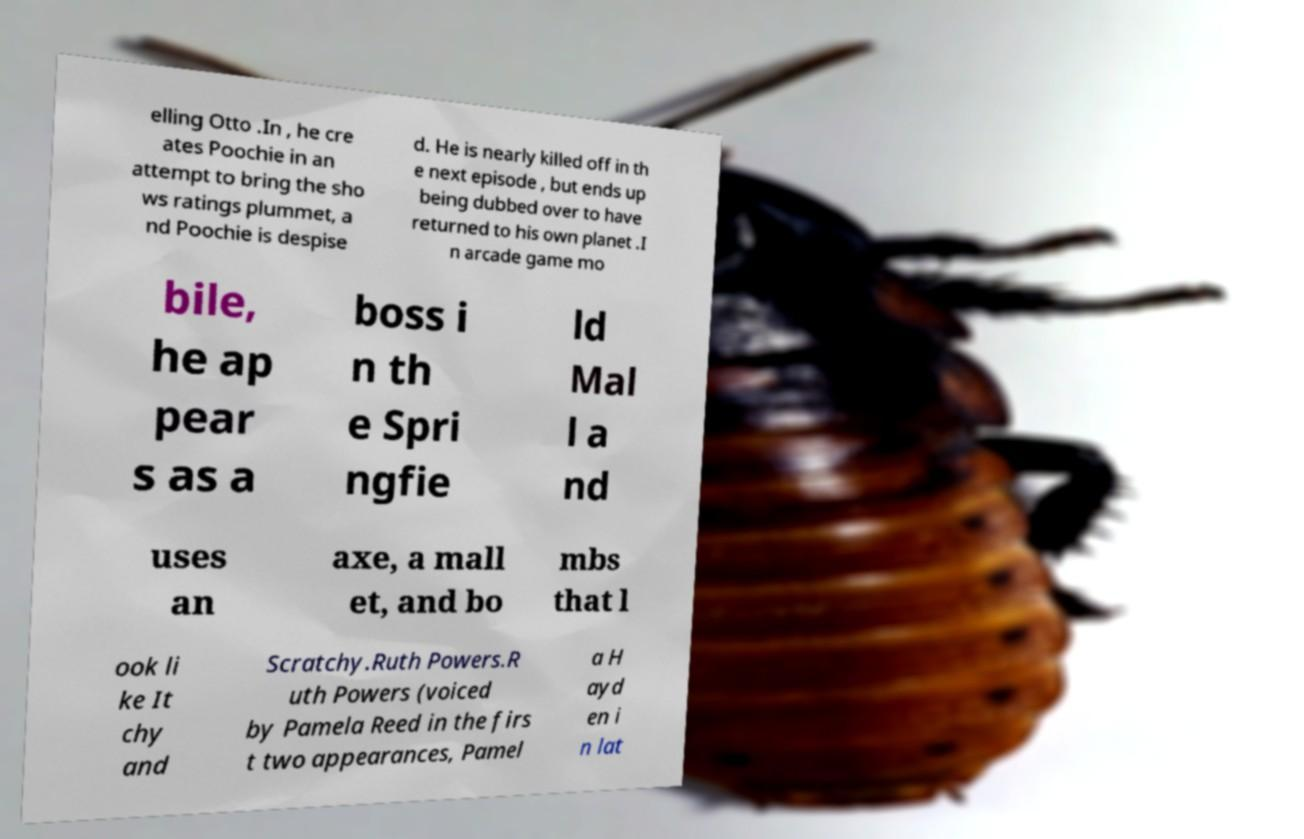Could you assist in decoding the text presented in this image and type it out clearly? elling Otto .In , he cre ates Poochie in an attempt to bring the sho ws ratings plummet, a nd Poochie is despise d. He is nearly killed off in th e next episode , but ends up being dubbed over to have returned to his own planet .I n arcade game mo bile, he ap pear s as a boss i n th e Spri ngfie ld Mal l a nd uses an axe, a mall et, and bo mbs that l ook li ke It chy and Scratchy.Ruth Powers.R uth Powers (voiced by Pamela Reed in the firs t two appearances, Pamel a H ayd en i n lat 